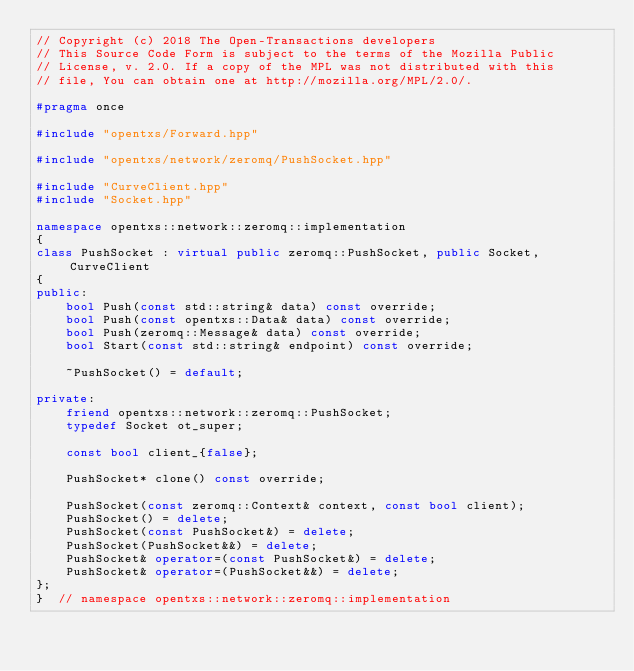<code> <loc_0><loc_0><loc_500><loc_500><_C++_>// Copyright (c) 2018 The Open-Transactions developers
// This Source Code Form is subject to the terms of the Mozilla Public
// License, v. 2.0. If a copy of the MPL was not distributed with this
// file, You can obtain one at http://mozilla.org/MPL/2.0/.

#pragma once

#include "opentxs/Forward.hpp"

#include "opentxs/network/zeromq/PushSocket.hpp"

#include "CurveClient.hpp"
#include "Socket.hpp"

namespace opentxs::network::zeromq::implementation
{
class PushSocket : virtual public zeromq::PushSocket, public Socket, CurveClient
{
public:
    bool Push(const std::string& data) const override;
    bool Push(const opentxs::Data& data) const override;
    bool Push(zeromq::Message& data) const override;
    bool Start(const std::string& endpoint) const override;

    ~PushSocket() = default;

private:
    friend opentxs::network::zeromq::PushSocket;
    typedef Socket ot_super;

    const bool client_{false};

    PushSocket* clone() const override;

    PushSocket(const zeromq::Context& context, const bool client);
    PushSocket() = delete;
    PushSocket(const PushSocket&) = delete;
    PushSocket(PushSocket&&) = delete;
    PushSocket& operator=(const PushSocket&) = delete;
    PushSocket& operator=(PushSocket&&) = delete;
};
}  // namespace opentxs::network::zeromq::implementation
</code> 